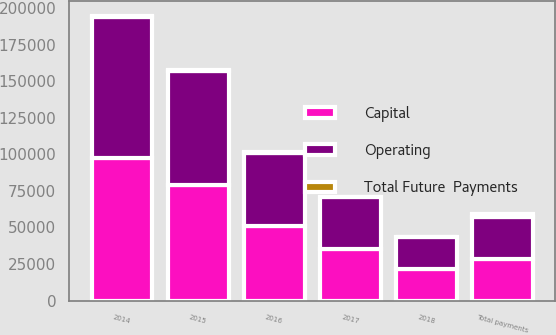Convert chart. <chart><loc_0><loc_0><loc_500><loc_500><stacked_bar_chart><ecel><fcel>2014<fcel>2015<fcel>2016<fcel>2017<fcel>2018<fcel>Total payments<nl><fcel>Total Future  Payments<fcel>771<fcel>458<fcel>462<fcel>266<fcel>41<fcel>1998<nl><fcel>Operating<fcel>96694<fcel>78301<fcel>50415<fcel>35239<fcel>21644<fcel>28462<nl><fcel>Capital<fcel>97465<fcel>78759<fcel>50877<fcel>35505<fcel>21685<fcel>28462<nl></chart> 